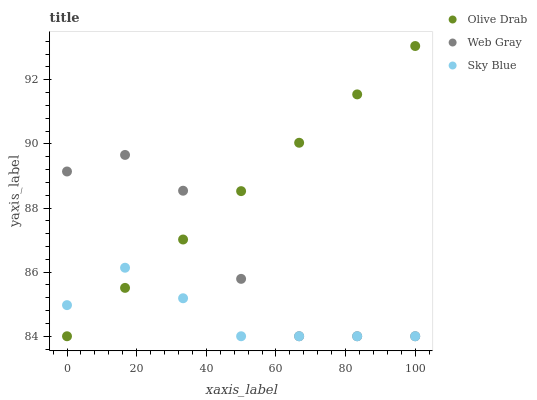Does Sky Blue have the minimum area under the curve?
Answer yes or no. Yes. Does Olive Drab have the maximum area under the curve?
Answer yes or no. Yes. Does Web Gray have the minimum area under the curve?
Answer yes or no. No. Does Web Gray have the maximum area under the curve?
Answer yes or no. No. Is Olive Drab the smoothest?
Answer yes or no. Yes. Is Web Gray the roughest?
Answer yes or no. Yes. Is Web Gray the smoothest?
Answer yes or no. No. Is Olive Drab the roughest?
Answer yes or no. No. Does Sky Blue have the lowest value?
Answer yes or no. Yes. Does Olive Drab have the highest value?
Answer yes or no. Yes. Does Web Gray have the highest value?
Answer yes or no. No. Does Olive Drab intersect Web Gray?
Answer yes or no. Yes. Is Olive Drab less than Web Gray?
Answer yes or no. No. Is Olive Drab greater than Web Gray?
Answer yes or no. No. 